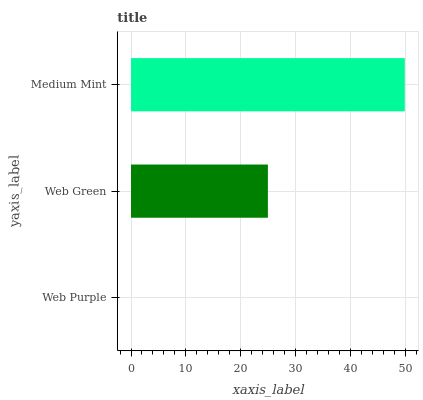Is Web Purple the minimum?
Answer yes or no. Yes. Is Medium Mint the maximum?
Answer yes or no. Yes. Is Web Green the minimum?
Answer yes or no. No. Is Web Green the maximum?
Answer yes or no. No. Is Web Green greater than Web Purple?
Answer yes or no. Yes. Is Web Purple less than Web Green?
Answer yes or no. Yes. Is Web Purple greater than Web Green?
Answer yes or no. No. Is Web Green less than Web Purple?
Answer yes or no. No. Is Web Green the high median?
Answer yes or no. Yes. Is Web Green the low median?
Answer yes or no. Yes. Is Medium Mint the high median?
Answer yes or no. No. Is Medium Mint the low median?
Answer yes or no. No. 